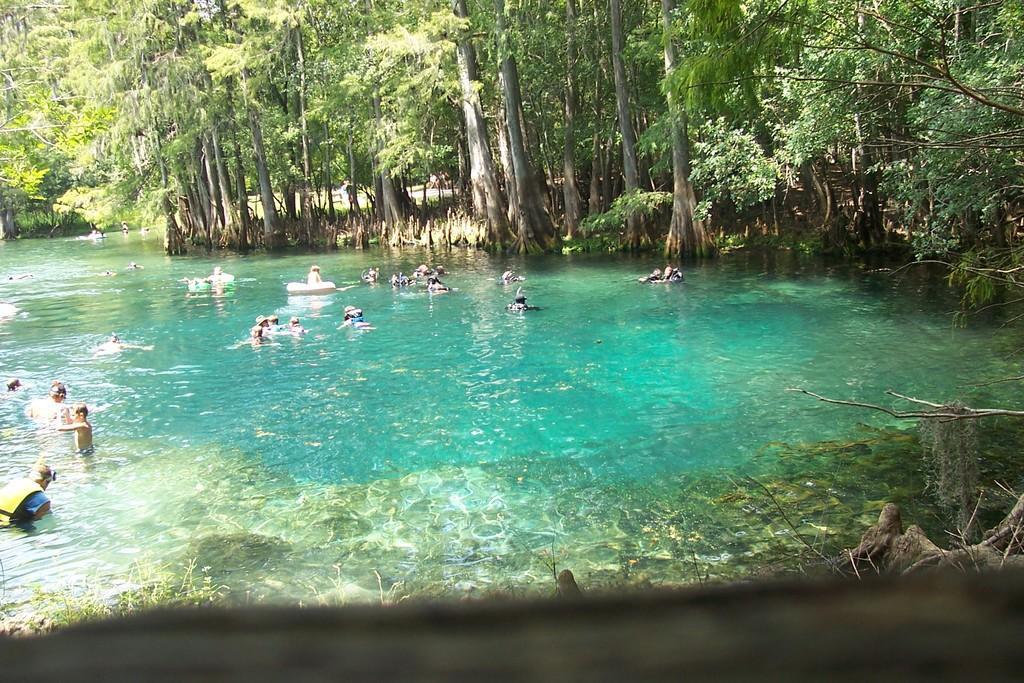Could you give a brief overview of what you see in this image? In the image there are few people swimming in the river and around the river there are many trees. 